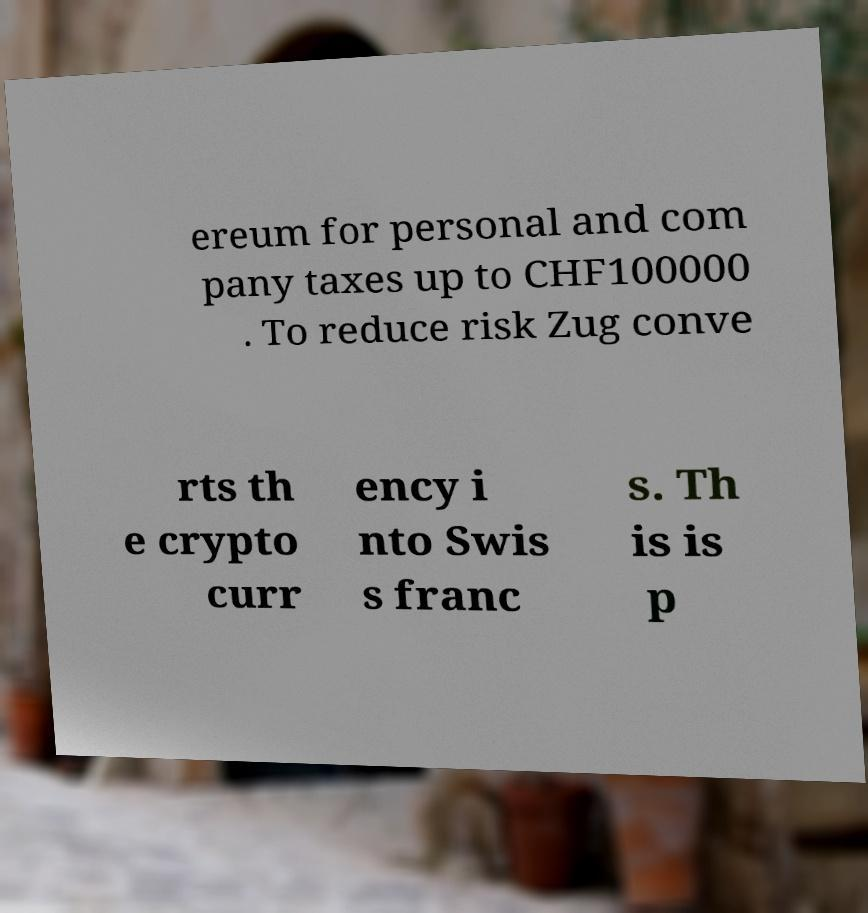For documentation purposes, I need the text within this image transcribed. Could you provide that? ereum for personal and com pany taxes up to CHF100000 . To reduce risk Zug conve rts th e crypto curr ency i nto Swis s franc s. Th is is p 